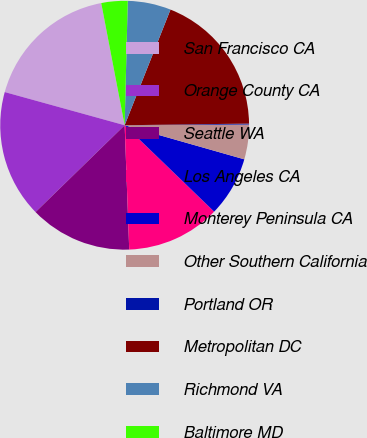<chart> <loc_0><loc_0><loc_500><loc_500><pie_chart><fcel>San Francisco CA<fcel>Orange County CA<fcel>Seattle WA<fcel>Los Angeles CA<fcel>Monterey Peninsula CA<fcel>Other Southern California<fcel>Portland OR<fcel>Metropolitan DC<fcel>Richmond VA<fcel>Baltimore MD<nl><fcel>17.69%<fcel>16.59%<fcel>13.29%<fcel>12.2%<fcel>7.8%<fcel>4.51%<fcel>0.12%<fcel>18.78%<fcel>5.61%<fcel>3.41%<nl></chart> 